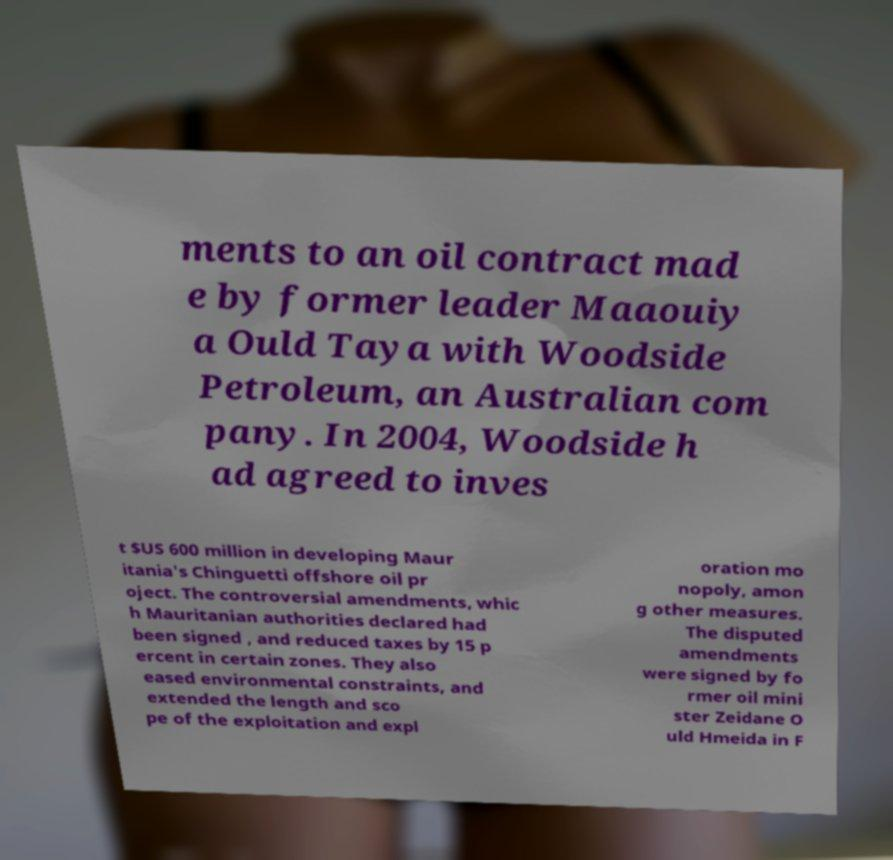Could you extract and type out the text from this image? ments to an oil contract mad e by former leader Maaouiy a Ould Taya with Woodside Petroleum, an Australian com pany. In 2004, Woodside h ad agreed to inves t $US 600 million in developing Maur itania's Chinguetti offshore oil pr oject. The controversial amendments, whic h Mauritanian authorities declared had been signed , and reduced taxes by 15 p ercent in certain zones. They also eased environmental constraints, and extended the length and sco pe of the exploitation and expl oration mo nopoly, amon g other measures. The disputed amendments were signed by fo rmer oil mini ster Zeidane O uld Hmeida in F 